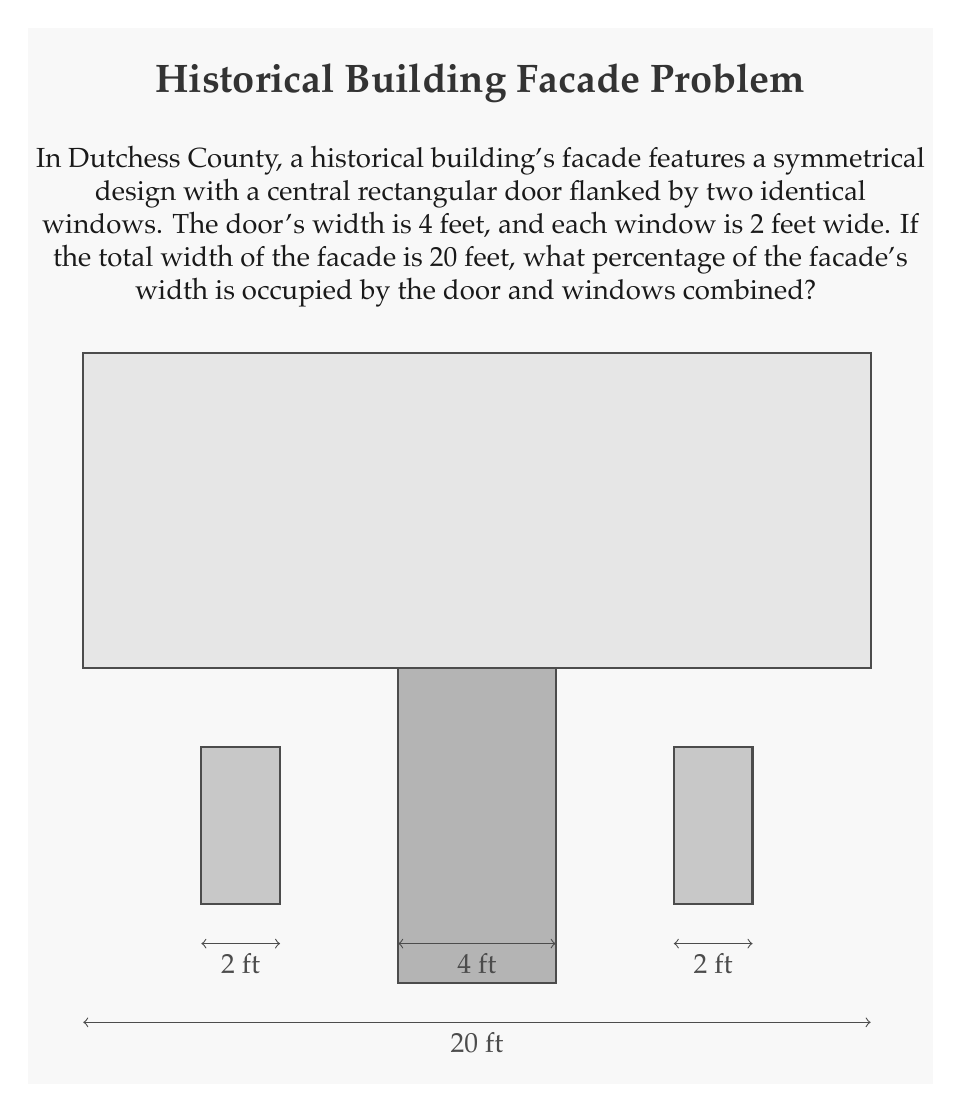Teach me how to tackle this problem. Let's approach this step-by-step:

1) First, we need to calculate the total width occupied by the door and windows:
   - Door width: 4 feet
   - Window width: 2 feet each
   - Total width of openings: $4 + 2 + 2 = 8$ feet

2) Now, we know:
   - Total facade width: 20 feet
   - Width occupied by openings: 8 feet

3) To calculate the percentage, we use the formula:
   $\text{Percentage} = \frac{\text{Part}}{\text{Whole}} \times 100\%$

4) Plugging in our values:
   $$\text{Percentage} = \frac{8}{20} \times 100\%$$

5) Simplify the fraction:
   $$\text{Percentage} = \frac{2}{5} \times 100\%$$

6) Calculate:
   $$\text{Percentage} = 0.4 \times 100\% = 40\%$$

Therefore, the door and windows combined occupy 40% of the facade's width.
Answer: 40% 